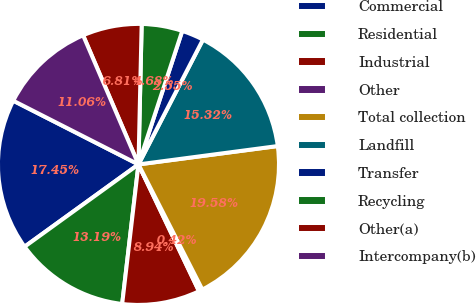Convert chart. <chart><loc_0><loc_0><loc_500><loc_500><pie_chart><fcel>Commercial<fcel>Residential<fcel>Industrial<fcel>Other<fcel>Total collection<fcel>Landfill<fcel>Transfer<fcel>Recycling<fcel>Other(a)<fcel>Intercompany(b)<nl><fcel>17.45%<fcel>13.19%<fcel>8.94%<fcel>0.42%<fcel>19.58%<fcel>15.32%<fcel>2.55%<fcel>4.68%<fcel>6.81%<fcel>11.06%<nl></chart> 